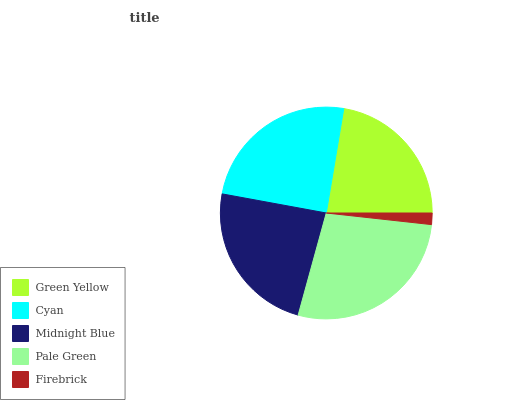Is Firebrick the minimum?
Answer yes or no. Yes. Is Pale Green the maximum?
Answer yes or no. Yes. Is Cyan the minimum?
Answer yes or no. No. Is Cyan the maximum?
Answer yes or no. No. Is Cyan greater than Green Yellow?
Answer yes or no. Yes. Is Green Yellow less than Cyan?
Answer yes or no. Yes. Is Green Yellow greater than Cyan?
Answer yes or no. No. Is Cyan less than Green Yellow?
Answer yes or no. No. Is Midnight Blue the high median?
Answer yes or no. Yes. Is Midnight Blue the low median?
Answer yes or no. Yes. Is Green Yellow the high median?
Answer yes or no. No. Is Firebrick the low median?
Answer yes or no. No. 